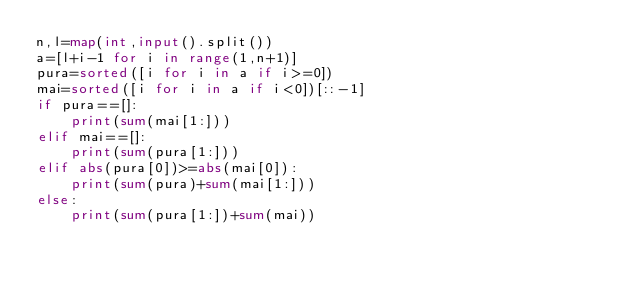Convert code to text. <code><loc_0><loc_0><loc_500><loc_500><_Python_>n,l=map(int,input().split())
a=[l+i-1 for i in range(1,n+1)]
pura=sorted([i for i in a if i>=0])
mai=sorted([i for i in a if i<0])[::-1]
if pura==[]:
    print(sum(mai[1:]))
elif mai==[]:
    print(sum(pura[1:]))
elif abs(pura[0])>=abs(mai[0]):
    print(sum(pura)+sum(mai[1:]))
else:
    print(sum(pura[1:])+sum(mai))</code> 